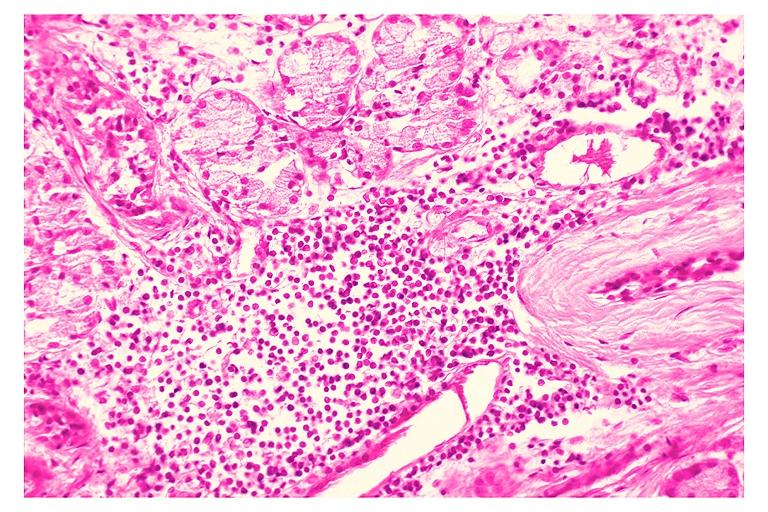does this image show chronic sialadenitis?
Answer the question using a single word or phrase. Yes 